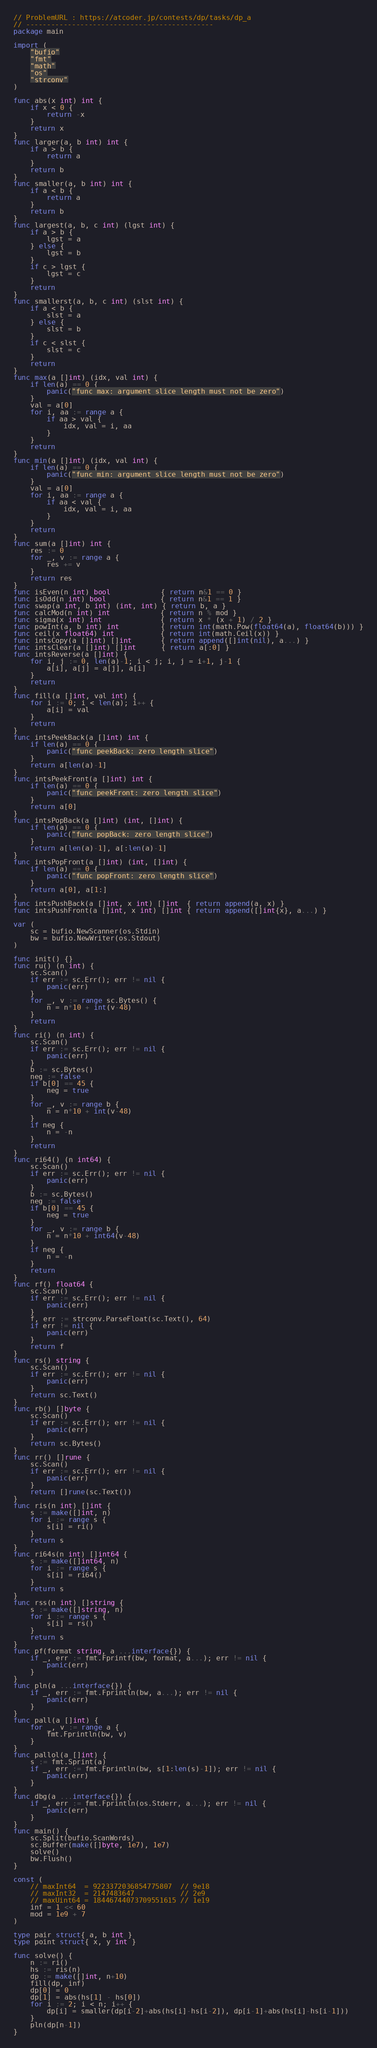Convert code to text. <code><loc_0><loc_0><loc_500><loc_500><_Go_>// ProblemURL : https://atcoder.jp/contests/dp/tasks/dp_a
// ---------------------------------------------
package main

import (
	"bufio"
	"fmt"
	"math"
	"os"
	"strconv"
)

func abs(x int) int {
	if x < 0 {
		return -x
	}
	return x
}
func larger(a, b int) int {
	if a > b {
		return a
	}
	return b
}
func smaller(a, b int) int {
	if a < b {
		return a
	}
	return b
}
func largest(a, b, c int) (lgst int) {
	if a > b {
		lgst = a
	} else {
		lgst = b
	}
	if c > lgst {
		lgst = c
	}
	return
}
func smallerst(a, b, c int) (slst int) {
	if a < b {
		slst = a
	} else {
		slst = b
	}
	if c < slst {
		slst = c
	}
	return
}
func max(a []int) (idx, val int) {
	if len(a) == 0 {
		panic("func max: argument slice length must not be zero")
	}
	val = a[0]
	for i, aa := range a {
		if aa > val {
			idx, val = i, aa
		}
	}
	return
}
func min(a []int) (idx, val int) {
	if len(a) == 0 {
		panic("func min: argument slice length must not be zero")
	}
	val = a[0]
	for i, aa := range a {
		if aa < val {
			idx, val = i, aa
		}
	}
	return
}
func sum(a []int) int {
	res := 0
	for _, v := range a {
		res += v
	}
	return res
}
func isEven(n int) bool            { return n&1 == 0 }
func isOdd(n int) bool             { return n&1 == 1 }
func swap(a int, b int) (int, int) { return b, a }
func calcMod(n int) int            { return n % mod }
func sigma(x int) int              { return x * (x + 1) / 2 }
func powInt(a, b int) int          { return int(math.Pow(float64(a), float64(b))) }
func ceil(x float64) int           { return int(math.Ceil(x)) }
func intsCopy(a []int) []int       { return append([]int(nil), a...) }
func intsClear(a []int) []int      { return a[:0] }
func intsReverse(a []int) {
	for i, j := 0, len(a)-1; i < j; i, j = i+1, j-1 {
		a[i], a[j] = a[j], a[i]
	}
	return
}
func fill(a []int, val int) {
	for i := 0; i < len(a); i++ {
		a[i] = val
	}
	return
}
func intsPeekBack(a []int) int {
	if len(a) == 0 {
		panic("func peekBack: zero length slice")
	}
	return a[len(a)-1]
}
func intsPeekFront(a []int) int {
	if len(a) == 0 {
		panic("func peekFront: zero length slice")
	}
	return a[0]
}
func intsPopBack(a []int) (int, []int) {
	if len(a) == 0 {
		panic("func popBack: zero length slice")
	}
	return a[len(a)-1], a[:len(a)-1]
}
func intsPopFront(a []int) (int, []int) {
	if len(a) == 0 {
		panic("func popFront: zero length slice")
	}
	return a[0], a[1:]
}
func intsPushBack(a []int, x int) []int  { return append(a, x) }
func intsPushFront(a []int, x int) []int { return append([]int{x}, a...) }

var (
	sc = bufio.NewScanner(os.Stdin)
	bw = bufio.NewWriter(os.Stdout)
)

func init() {}
func ru() (n int) {
	sc.Scan()
	if err := sc.Err(); err != nil {
		panic(err)
	}
	for _, v := range sc.Bytes() {
		n = n*10 + int(v-48)
	}
	return
}
func ri() (n int) {
	sc.Scan()
	if err := sc.Err(); err != nil {
		panic(err)
	}
	b := sc.Bytes()
	neg := false
	if b[0] == 45 {
		neg = true
	}
	for _, v := range b {
		n = n*10 + int(v-48)
	}
	if neg {
		n = -n
	}
	return
}
func ri64() (n int64) {
	sc.Scan()
	if err := sc.Err(); err != nil {
		panic(err)
	}
	b := sc.Bytes()
	neg := false
	if b[0] == 45 {
		neg = true
	}
	for _, v := range b {
		n = n*10 + int64(v-48)
	}
	if neg {
		n = -n
	}
	return
}
func rf() float64 {
	sc.Scan()
	if err := sc.Err(); err != nil {
		panic(err)
	}
	f, err := strconv.ParseFloat(sc.Text(), 64)
	if err != nil {
		panic(err)
	}
	return f
}
func rs() string {
	sc.Scan()
	if err := sc.Err(); err != nil {
		panic(err)
	}
	return sc.Text()
}
func rb() []byte {
	sc.Scan()
	if err := sc.Err(); err != nil {
		panic(err)
	}
	return sc.Bytes()
}
func rr() []rune {
	sc.Scan()
	if err := sc.Err(); err != nil {
		panic(err)
	}
	return []rune(sc.Text())
}
func ris(n int) []int {
	s := make([]int, n)
	for i := range s {
		s[i] = ri()
	}
	return s
}
func ri64s(n int) []int64 {
	s := make([]int64, n)
	for i := range s {
		s[i] = ri64()
	}
	return s
}
func rss(n int) []string {
	s := make([]string, n)
	for i := range s {
		s[i] = rs()
	}
	return s
}
func pf(format string, a ...interface{}) {
	if _, err := fmt.Fprintf(bw, format, a...); err != nil {
		panic(err)
	}
}
func pln(a ...interface{}) {
	if _, err := fmt.Fprintln(bw, a...); err != nil {
		panic(err)
	}
}
func pall(a []int) {
	for _, v := range a {
		fmt.Fprintln(bw, v)
	}
}
func pallol(a []int) {
	s := fmt.Sprint(a)
	if _, err := fmt.Fprintln(bw, s[1:len(s)-1]); err != nil {
		panic(err)
	}
}
func dbg(a ...interface{}) {
	if _, err := fmt.Fprintln(os.Stderr, a...); err != nil {
		panic(err)
	}
}
func main() {
	sc.Split(bufio.ScanWords)
	sc.Buffer(make([]byte, 1e7), 1e7)
	solve()
	bw.Flush()
}

const (
	// maxInt64  = 9223372036854775807  // 9e18
	// maxInt32  = 2147483647           // 2e9
	// maxUint64 = 18446744073709551615 // 1e19
	inf = 1 << 60
	mod = 1e9 + 7
)

type pair struct{ a, b int }
type point struct{ x, y int }

func solve() {
	n := ri()
	hs := ris(n)
	dp := make([]int, n+10)
	fill(dp, inf)
	dp[0] = 0
	dp[1] = abs(hs[1] - hs[0])
	for i := 2; i < n; i++ {
		dp[i] = smaller(dp[i-2]+abs(hs[i]-hs[i-2]), dp[i-1]+abs(hs[i]-hs[i-1]))
	}
	pln(dp[n-1])
}
</code> 